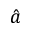<formula> <loc_0><loc_0><loc_500><loc_500>\hat { a }</formula> 